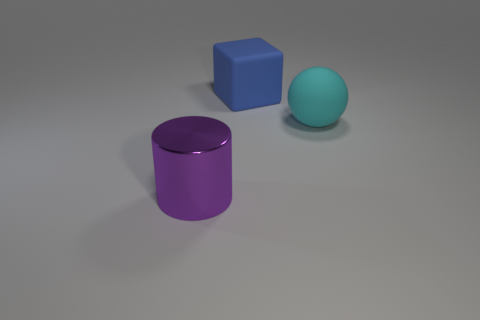Is there any other thing that is made of the same material as the purple cylinder?
Keep it short and to the point. No. What number of things are either large blue matte objects or big purple cylinders?
Your answer should be very brief. 2. There is a object that is behind the purple cylinder and in front of the blue rubber block; how big is it?
Give a very brief answer. Large. How many large shiny blocks are there?
Ensure brevity in your answer.  0. How many balls are cyan matte objects or blue objects?
Your answer should be very brief. 1. How many big cyan spheres are behind the object that is behind the matte object in front of the large cube?
Provide a short and direct response. 0. There is a matte cube that is the same size as the purple cylinder; what is its color?
Provide a succinct answer. Blue. Is the number of big blue matte things in front of the cyan matte ball greater than the number of red objects?
Provide a succinct answer. No. Do the big cyan sphere and the big block have the same material?
Keep it short and to the point. Yes. What number of objects are large things that are on the right side of the purple object or tiny green metal cubes?
Offer a terse response. 2. 